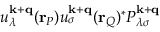<formula> <loc_0><loc_0><loc_500><loc_500>u _ { \lambda } ^ { k + q } ( r _ { P } ) u _ { \sigma } ^ { k + q } ( r _ { Q } ) ^ { * } P _ { \lambda \sigma } ^ { k + q }</formula> 